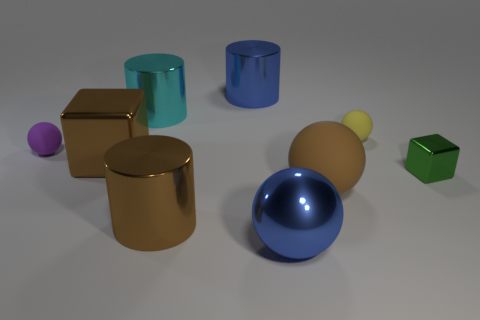Is the color of the big block the same as the big rubber thing?
Keep it short and to the point. Yes. What is the material of the purple sphere?
Provide a succinct answer. Rubber. The matte ball that is in front of the large brown metallic object behind the cube that is right of the cyan shiny object is what color?
Your answer should be compact. Brown. How many green metal cubes are the same size as the purple ball?
Offer a terse response. 1. There is a tiny rubber object that is behind the small purple rubber ball; what color is it?
Your answer should be compact. Yellow. What number of other objects are there of the same size as the metallic ball?
Ensure brevity in your answer.  5. What size is the rubber thing that is behind the tiny green metallic thing and in front of the yellow rubber ball?
Offer a terse response. Small. There is a big rubber thing; is it the same color as the large cylinder in front of the green block?
Your response must be concise. Yes. Are there any green rubber objects of the same shape as the purple rubber object?
Your answer should be compact. No. What number of objects are tiny blocks or metallic cylinders in front of the green object?
Ensure brevity in your answer.  2. 